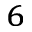<formula> <loc_0><loc_0><loc_500><loc_500>_ { 6 }</formula> 